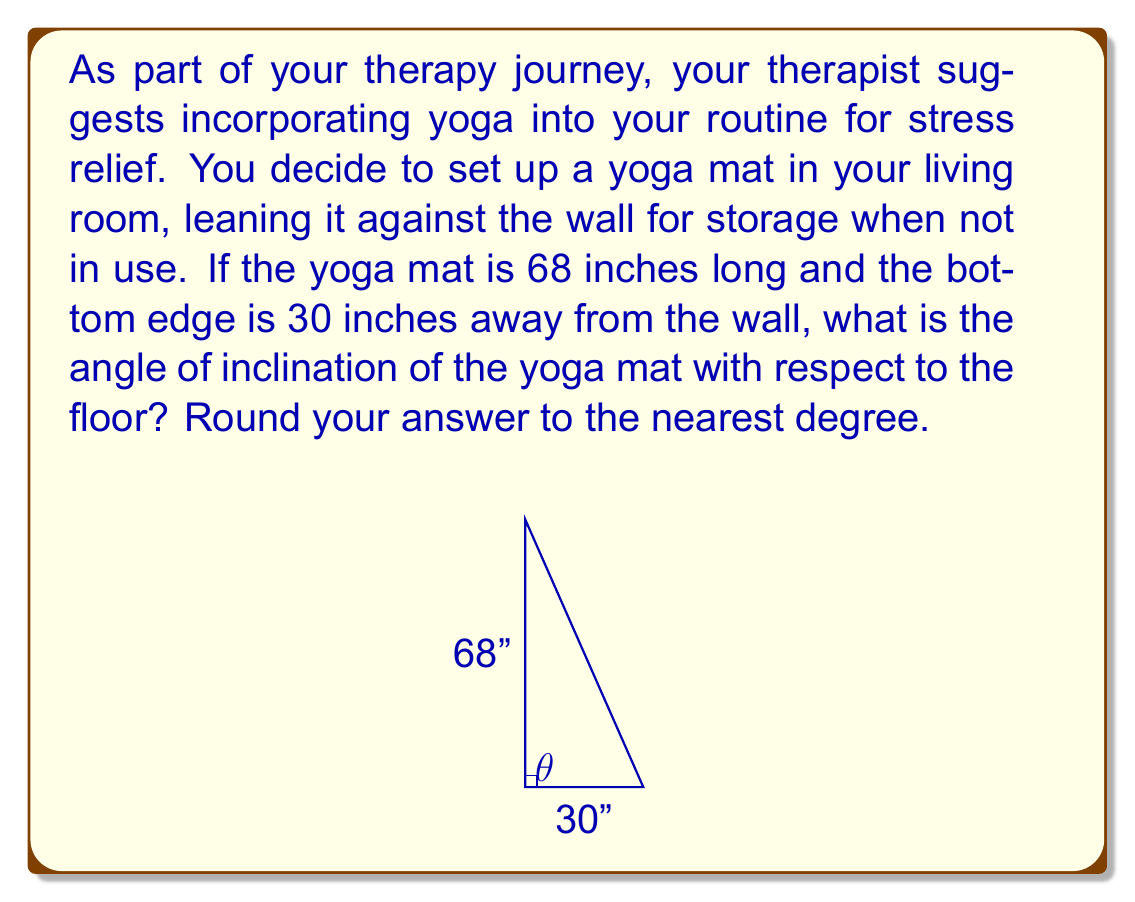Can you answer this question? Let's approach this step-by-step:

1) The yoga mat and the floor form a right triangle. We know:
   - The length of the yoga mat (hypotenuse) = 68 inches
   - The distance from the wall to the mat's bottom edge (adjacent side) = 30 inches

2) We need to find the angle between the mat and the floor. This is the angle of inclination, which we'll call $\theta$.

3) In a right triangle, we can use the inverse cosine function (arccos) to find an angle when we know the adjacent side and hypotenuse.

4) The cosine of an angle in a right triangle is given by:

   $$\cos \theta = \frac{\text{adjacent}}{\text{hypotenuse}}$$

5) Substituting our known values:

   $$\cos \theta = \frac{30}{68}$$

6) To find $\theta$, we take the inverse cosine (arccos) of both sides:

   $$\theta = \arccos(\frac{30}{68})$$

7) Using a calculator or computer:

   $$\theta \approx 63.89^\circ$$

8) Rounding to the nearest degree:

   $$\theta \approx 64^\circ$$
Answer: The angle of inclination of the yoga mat is approximately 64°. 